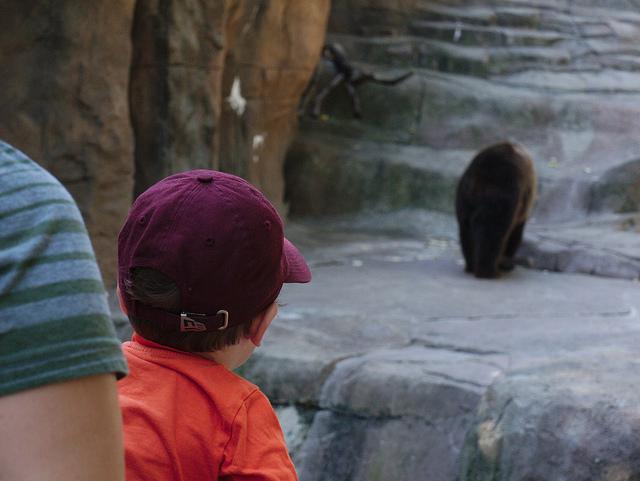How many mammals are in this scene?
Be succinct. 3. Can see the animals face?
Concise answer only. No. Is the kid's shirt blue?
Short answer required. No. 